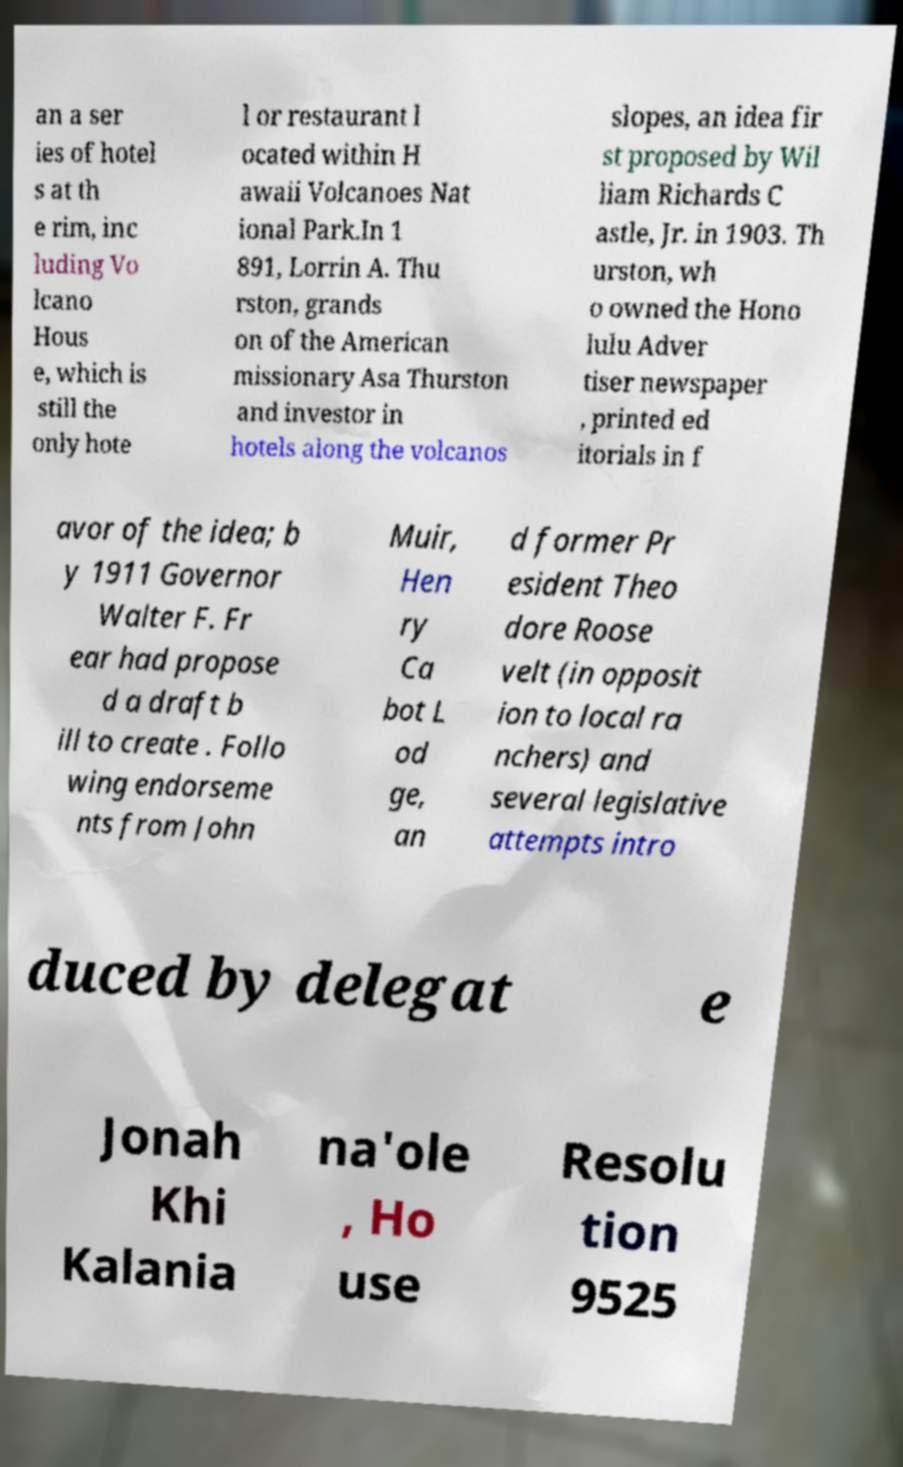Can you accurately transcribe the text from the provided image for me? an a ser ies of hotel s at th e rim, inc luding Vo lcano Hous e, which is still the only hote l or restaurant l ocated within H awaii Volcanoes Nat ional Park.In 1 891, Lorrin A. Thu rston, grands on of the American missionary Asa Thurston and investor in hotels along the volcanos slopes, an idea fir st proposed by Wil liam Richards C astle, Jr. in 1903. Th urston, wh o owned the Hono lulu Adver tiser newspaper , printed ed itorials in f avor of the idea; b y 1911 Governor Walter F. Fr ear had propose d a draft b ill to create . Follo wing endorseme nts from John Muir, Hen ry Ca bot L od ge, an d former Pr esident Theo dore Roose velt (in opposit ion to local ra nchers) and several legislative attempts intro duced by delegat e Jonah Khi Kalania na'ole , Ho use Resolu tion 9525 